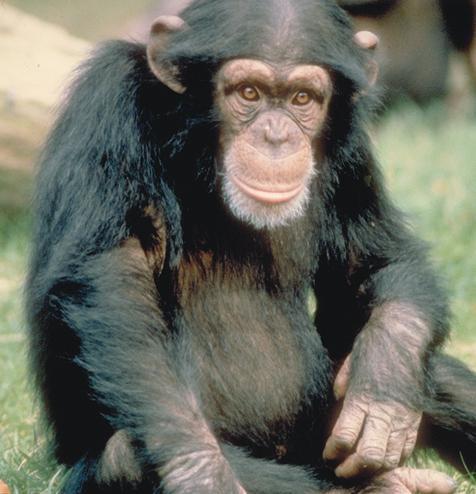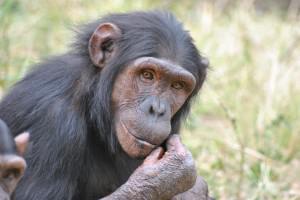The first image is the image on the left, the second image is the image on the right. Evaluate the accuracy of this statement regarding the images: "An image includes a camera-facing chimp with a wide-open mouth showing at least one row of teeth.". Is it true? Answer yes or no. No. The first image is the image on the left, the second image is the image on the right. Given the left and right images, does the statement "One animal in the image on the left is baring its teeth." hold true? Answer yes or no. No. 